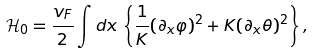Convert formula to latex. <formula><loc_0><loc_0><loc_500><loc_500>\mathcal { H } _ { 0 } = \frac { v _ { F } } { 2 } \int d x \, \left \{ \frac { 1 } { K } ( \partial _ { x } \varphi ) ^ { 2 } + K ( \partial _ { x } \theta ) ^ { 2 } \right \} ,</formula> 